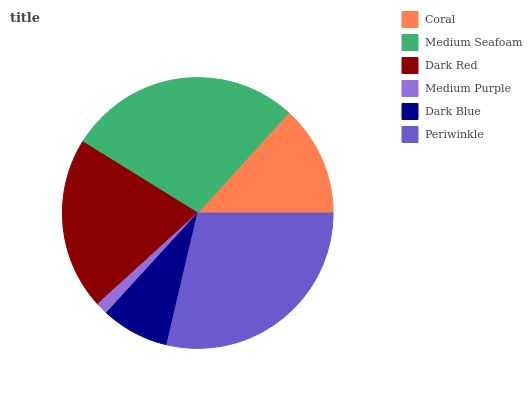Is Medium Purple the minimum?
Answer yes or no. Yes. Is Periwinkle the maximum?
Answer yes or no. Yes. Is Medium Seafoam the minimum?
Answer yes or no. No. Is Medium Seafoam the maximum?
Answer yes or no. No. Is Medium Seafoam greater than Coral?
Answer yes or no. Yes. Is Coral less than Medium Seafoam?
Answer yes or no. Yes. Is Coral greater than Medium Seafoam?
Answer yes or no. No. Is Medium Seafoam less than Coral?
Answer yes or no. No. Is Dark Red the high median?
Answer yes or no. Yes. Is Coral the low median?
Answer yes or no. Yes. Is Medium Seafoam the high median?
Answer yes or no. No. Is Periwinkle the low median?
Answer yes or no. No. 